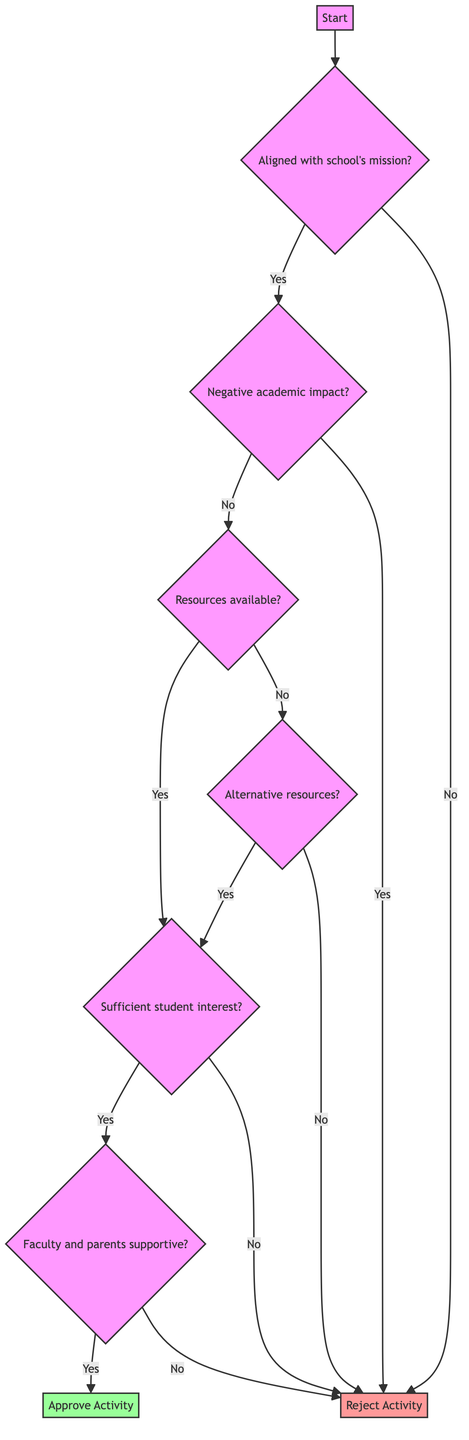What is the first question in the decision tree? The first question in the decision tree is found at the "Start" node, which asks if the Extra-Curricular Activity is aligned with the school's mission and values.
Answer: Is the Extra-Curricular Activity aligned with the school's mission and values? How many nodes are shown in the diagram? To determine the number of nodes, we count each distinct point in the decision tree, which includes all questions and end points. There are eight nodes in total.
Answer: 8 What happens if the activity is not aligned with the school's mission? If the Extra-Curricular Activity is not aligned, the decision tree indicates that the activity will be rejected immediately at that node.
Answer: Reject Activity What do we assess after checking the academic impact? After checking the academic impact, the next step is to assess resource availability to continue determining the feasibility of the activity.
Answer: Assess Resource Availability If there are alternative resources available, what is the next step? If alternative resources are available, the decision tree directs the next step to evaluate student interest in the Extra-Curricular Activity to gauge support.
Answer: Evaluate Student Interest How many paths lead to rejecting the activity? By analyzing the paths leading to rejection, there are four distinct paths that result in rejecting the activity, either due to alignment, academic impact, resource availability, or insufficient student interest or alternative resources.
Answer: 4 What is the final step if faculty and parents are supportive? If both faculty and parents are supportive, the final step of the flow is to approve the activity, which confirms its acceptance into the school’s roster of activities.
Answer: Approve Activity What is the condition to consult with faculty and parents? Consulting with faculty and parents occurs if there is sufficient student interest in the Extra-Curricular Activity, indicating a need for further stakeholder engagement.
Answer: Sufficient student interest in the activity What does the diagram conclude if there is no sufficient student interest? If there is no sufficient student interest, the path immediately leads to rejecting the activity, indicating that without interest, the activity cannot proceed.
Answer: Reject Activity 